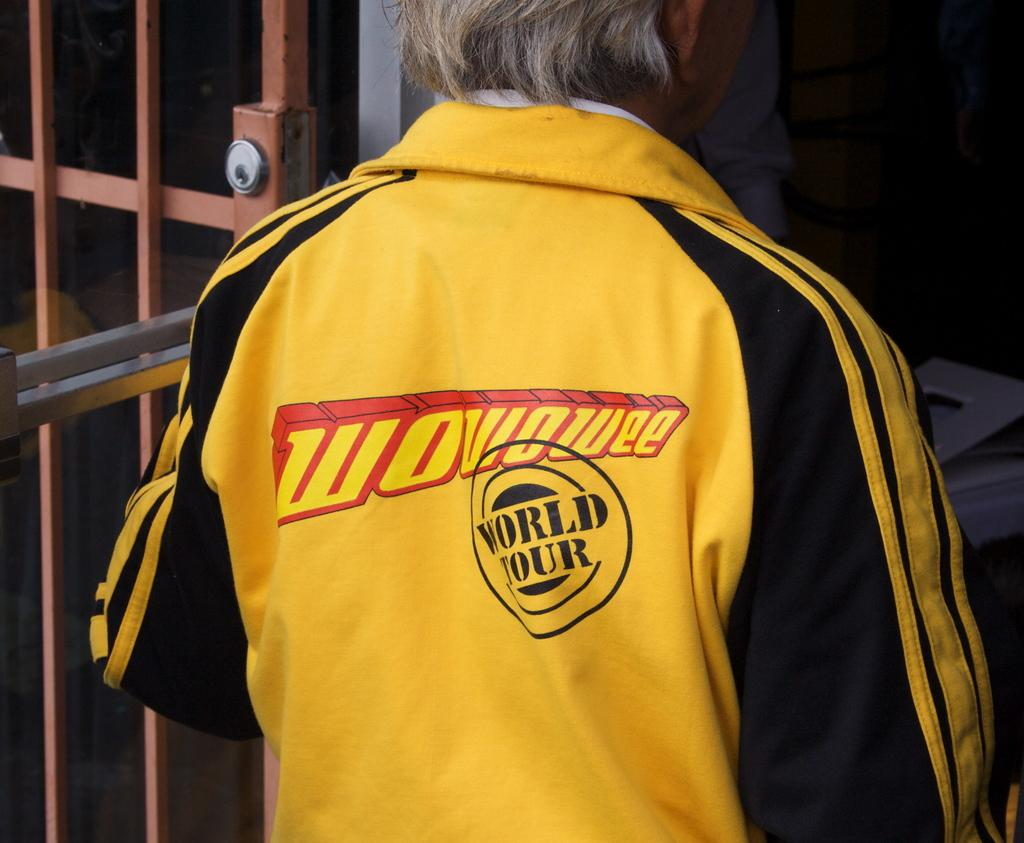<image>
Offer a succinct explanation of the picture presented. The back of man's yellow shirt reads "wowowee world tour." 